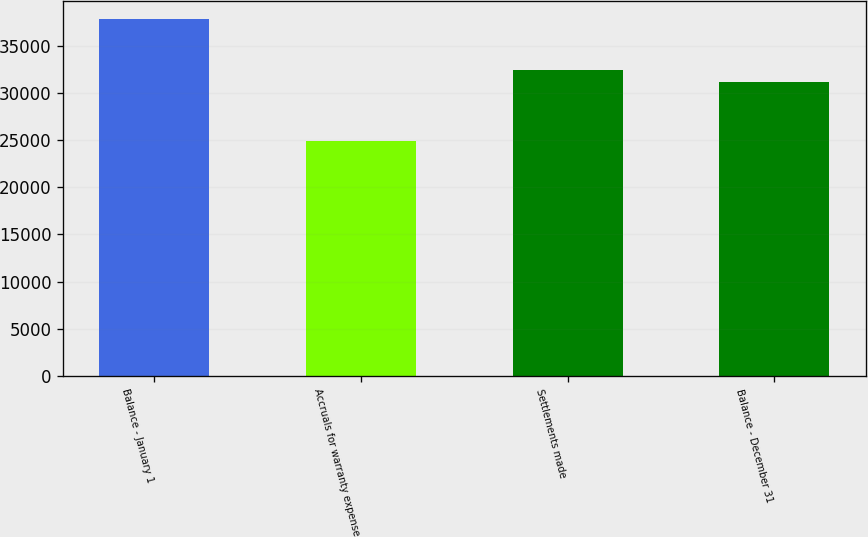Convert chart to OTSL. <chart><loc_0><loc_0><loc_500><loc_500><bar_chart><fcel>Balance - January 1<fcel>Accruals for warranty expense<fcel>Settlements made<fcel>Balance - December 31<nl><fcel>37828<fcel>24909<fcel>32386.9<fcel>31095<nl></chart> 